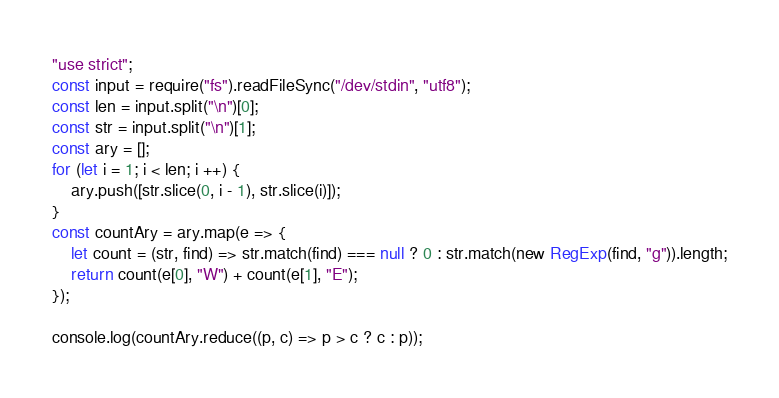Convert code to text. <code><loc_0><loc_0><loc_500><loc_500><_JavaScript_>"use strict";
const input = require("fs").readFileSync("/dev/stdin", "utf8");
const len = input.split("\n")[0];
const str = input.split("\n")[1];
const ary = [];
for (let i = 1; i < len; i ++) {
    ary.push([str.slice(0, i - 1), str.slice(i)]);
}
const countAry = ary.map(e => {
    let count = (str, find) => str.match(find) === null ? 0 : str.match(new RegExp(find, "g")).length;
    return count(e[0], "W") + count(e[1], "E");
});

console.log(countAry.reduce((p, c) => p > c ? c : p));</code> 